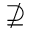Convert formula to latex. <formula><loc_0><loc_0><loc_500><loc_500>\nsupseteq</formula> 